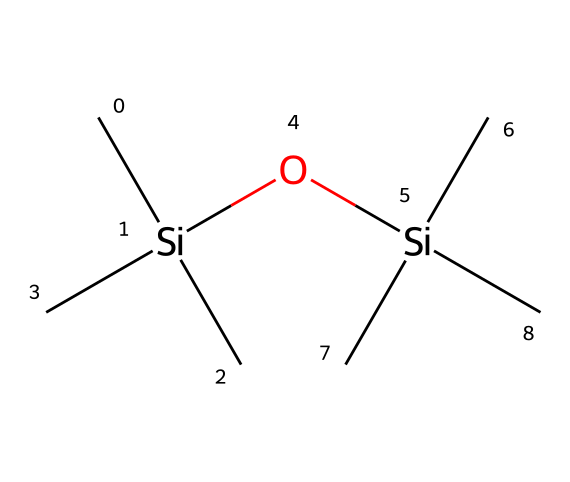What is the total number of silicon atoms in the structure? By examining the SMILES representation, there are two occurrences of the "Si" symbol, indicating two silicon atoms are present in the structure.
Answer: 2 How many carbon atoms are present in the molecule? The SMILES representation contains six "C" symbols before and after the "Si" atoms. This indicates there are six carbon atoms in total in the structure.
Answer: 6 What type of functional groups are present in this monomer? The presence of the "O" symbol in the SMILES indicates the presence of a siloxane functional group, and each silicon atom is bonded to an oxygen atom, typical for siloxanes.
Answer: siloxane What is the degree of branching in this siloxane monomer? The structure indicates that each silicon atom is connected to three carbon atoms, which reveals a highly branched structure typical of this type of siloxane.
Answer: highly branched How many total bonds are formed by each silicon atom? Each silicon atom is bonded to three carbon atoms and one oxygen atom, totaling four bonds formed by each of the silicon atoms in this structure.
Answer: 4 Is this siloxane monomer polar or nonpolar? Given that the molecule contains silicon and oxygen with carbon backbones, the polar Si-O bonds suggest the structure has polar characteristics overall; however, the overall structure is likely nonpolar due to symmetry.
Answer: nonpolar 